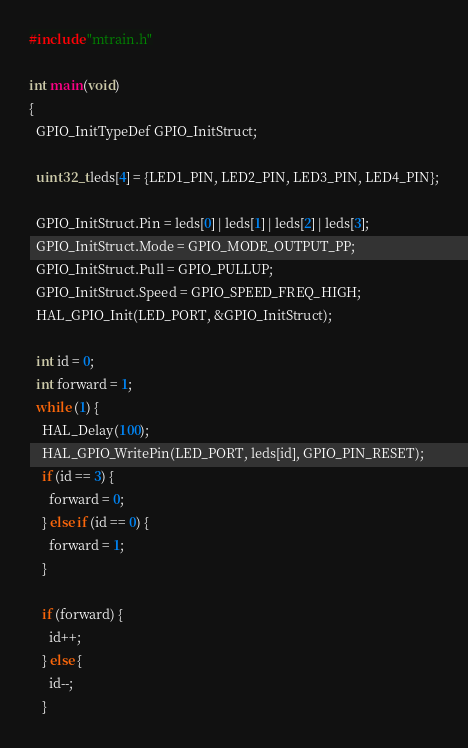<code> <loc_0><loc_0><loc_500><loc_500><_C_>#include "mtrain.h"

int main(void)
{
  GPIO_InitTypeDef GPIO_InitStruct;
  
  uint32_t leds[4] = {LED1_PIN, LED2_PIN, LED3_PIN, LED4_PIN};

  GPIO_InitStruct.Pin = leds[0] | leds[1] | leds[2] | leds[3];
  GPIO_InitStruct.Mode = GPIO_MODE_OUTPUT_PP;
  GPIO_InitStruct.Pull = GPIO_PULLUP;
  GPIO_InitStruct.Speed = GPIO_SPEED_FREQ_HIGH;
  HAL_GPIO_Init(LED_PORT, &GPIO_InitStruct);

  int id = 0;
  int forward = 1;
  while (1) {
    HAL_Delay(100);
    HAL_GPIO_WritePin(LED_PORT, leds[id], GPIO_PIN_RESET);
    if (id == 3) {
      forward = 0;
    } else if (id == 0) {
      forward = 1;
    }

    if (forward) {
      id++;
    } else {
      id--;
    }
</code> 